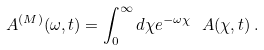Convert formula to latex. <formula><loc_0><loc_0><loc_500><loc_500>\ A ^ { ( M ) } ( \omega , t ) = \int _ { 0 } ^ { \infty } d \chi e ^ { - \omega \chi } \ A ( \chi , t ) \, .</formula> 